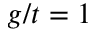Convert formula to latex. <formula><loc_0><loc_0><loc_500><loc_500>g / t = 1</formula> 